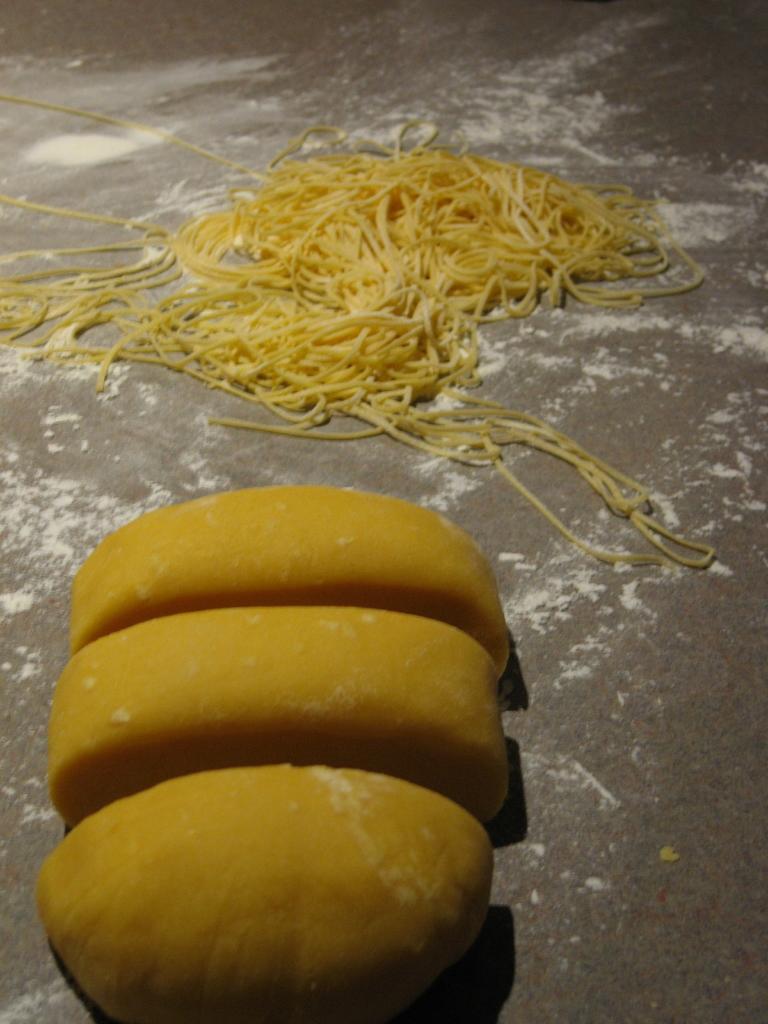Can you describe this image briefly? In the picture I can see some yellow color objects and some other objects are placed on the surface. 